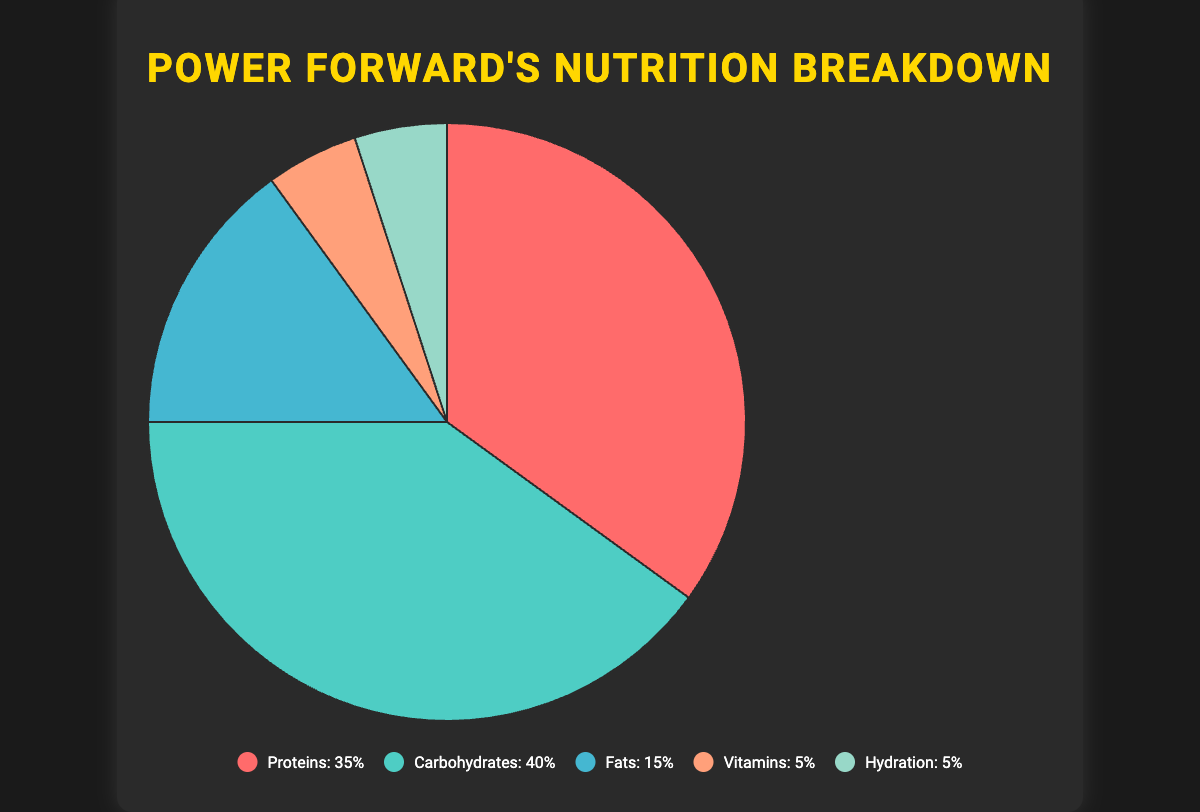What percentage of the diet is allocated to hydration? The slice labeled "Hydration" shows 5%.
Answer: 5% Which category has the highest percentage? By observing the pie chart, the slice labeled "Carbohydrates" is the largest, showing 40%.
Answer: Carbohydrates What is the total percentage for Proteins and Fats combined? Adding the percentage for Proteins (35%) and Fats (15%): 35 + 15 = 50%.
Answer: 50% Is the percentage of Carbohydrates greater than the sum of Vitamins and Hydration? Carbohydrates are 40%, and the sum of Vitamins and Hydration is 5% + 5% = 10%. Since 40% > 10%, Carbohydrates are greater.
Answer: Yes By how much does the percentage of Carbohydrates exceed that of Proteins? Carbohydrates are 40% and Proteins are 35%. The difference is 40 - 35 = 5%.
Answer: 5% Which category is represented by the pale green slice in the chart? The legend shows that the pale green slice represents Hydration.
Answer: Hydration If you combine the percentages of Vitamins and Fats, is it more or less than the percentage of Proteins? Adding Vitamins (5%) and Fats (15%): 5 + 15 = 20%, which is less than Proteins (35%).
Answer: Less Are Vitamins and Hydration represented by the same percentage? By observing the pie chart, both Vitamins and Hydration show 5%.
Answer: Yes Which two categories together make up half of the diet? Proteins (35%) and Fats (15%) combined form 35 + 15 = 50%.
Answer: Proteins and Fats What visual attribute distinguishes Carbohydrates from other categories in the pie chart? Carbohydrates are distinguished by the light blue slice in the pie chart.
Answer: Light blue slice 